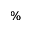<formula> <loc_0><loc_0><loc_500><loc_500>\%</formula> 